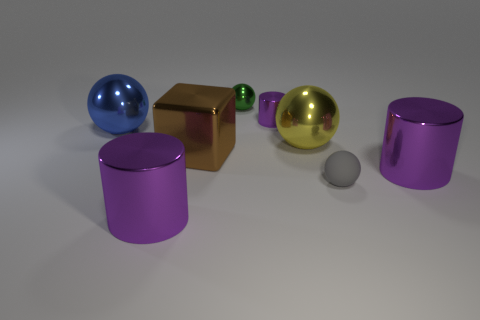There is a gray object that is the same shape as the blue object; what is it made of?
Provide a succinct answer. Rubber. Does the gray matte thing that is to the right of the blue object have the same shape as the tiny green thing?
Ensure brevity in your answer.  Yes. Are there any other things that are the same size as the gray matte ball?
Keep it short and to the point. Yes. Are there fewer small purple cylinders in front of the large yellow thing than small balls to the left of the green shiny thing?
Provide a short and direct response. No. How many other things are there of the same shape as the green metallic object?
Make the answer very short. 3. There is a purple object left of the metallic thing behind the small shiny thing on the right side of the green sphere; how big is it?
Offer a terse response. Large. How many brown things are either tiny metal objects or small blocks?
Ensure brevity in your answer.  0. There is a big purple metallic thing that is in front of the ball in front of the yellow thing; what shape is it?
Ensure brevity in your answer.  Cylinder. There is a purple metal cylinder that is behind the large blue object; does it have the same size as the ball behind the blue metal object?
Your response must be concise. Yes. Is there a large purple thing that has the same material as the green sphere?
Give a very brief answer. Yes. 